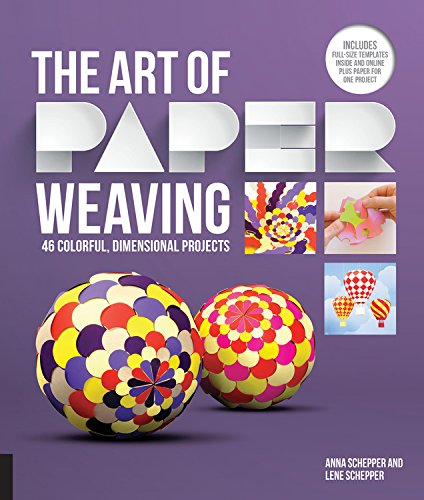Can you tell me about one of the projects featured in this book? Certainly! One of the projects featured in the book is creating colorful three-dimensional paper balls. These projects utilize intricate paper weaving techniques to achieve an eye-catching geometric pattern. What materials would be needed for this project? For this project, you would need colored paper, scissors, a paper weaving tool, and adhesive to secure the pieces. The book includes templates to help you cut the precise shapes needed. 